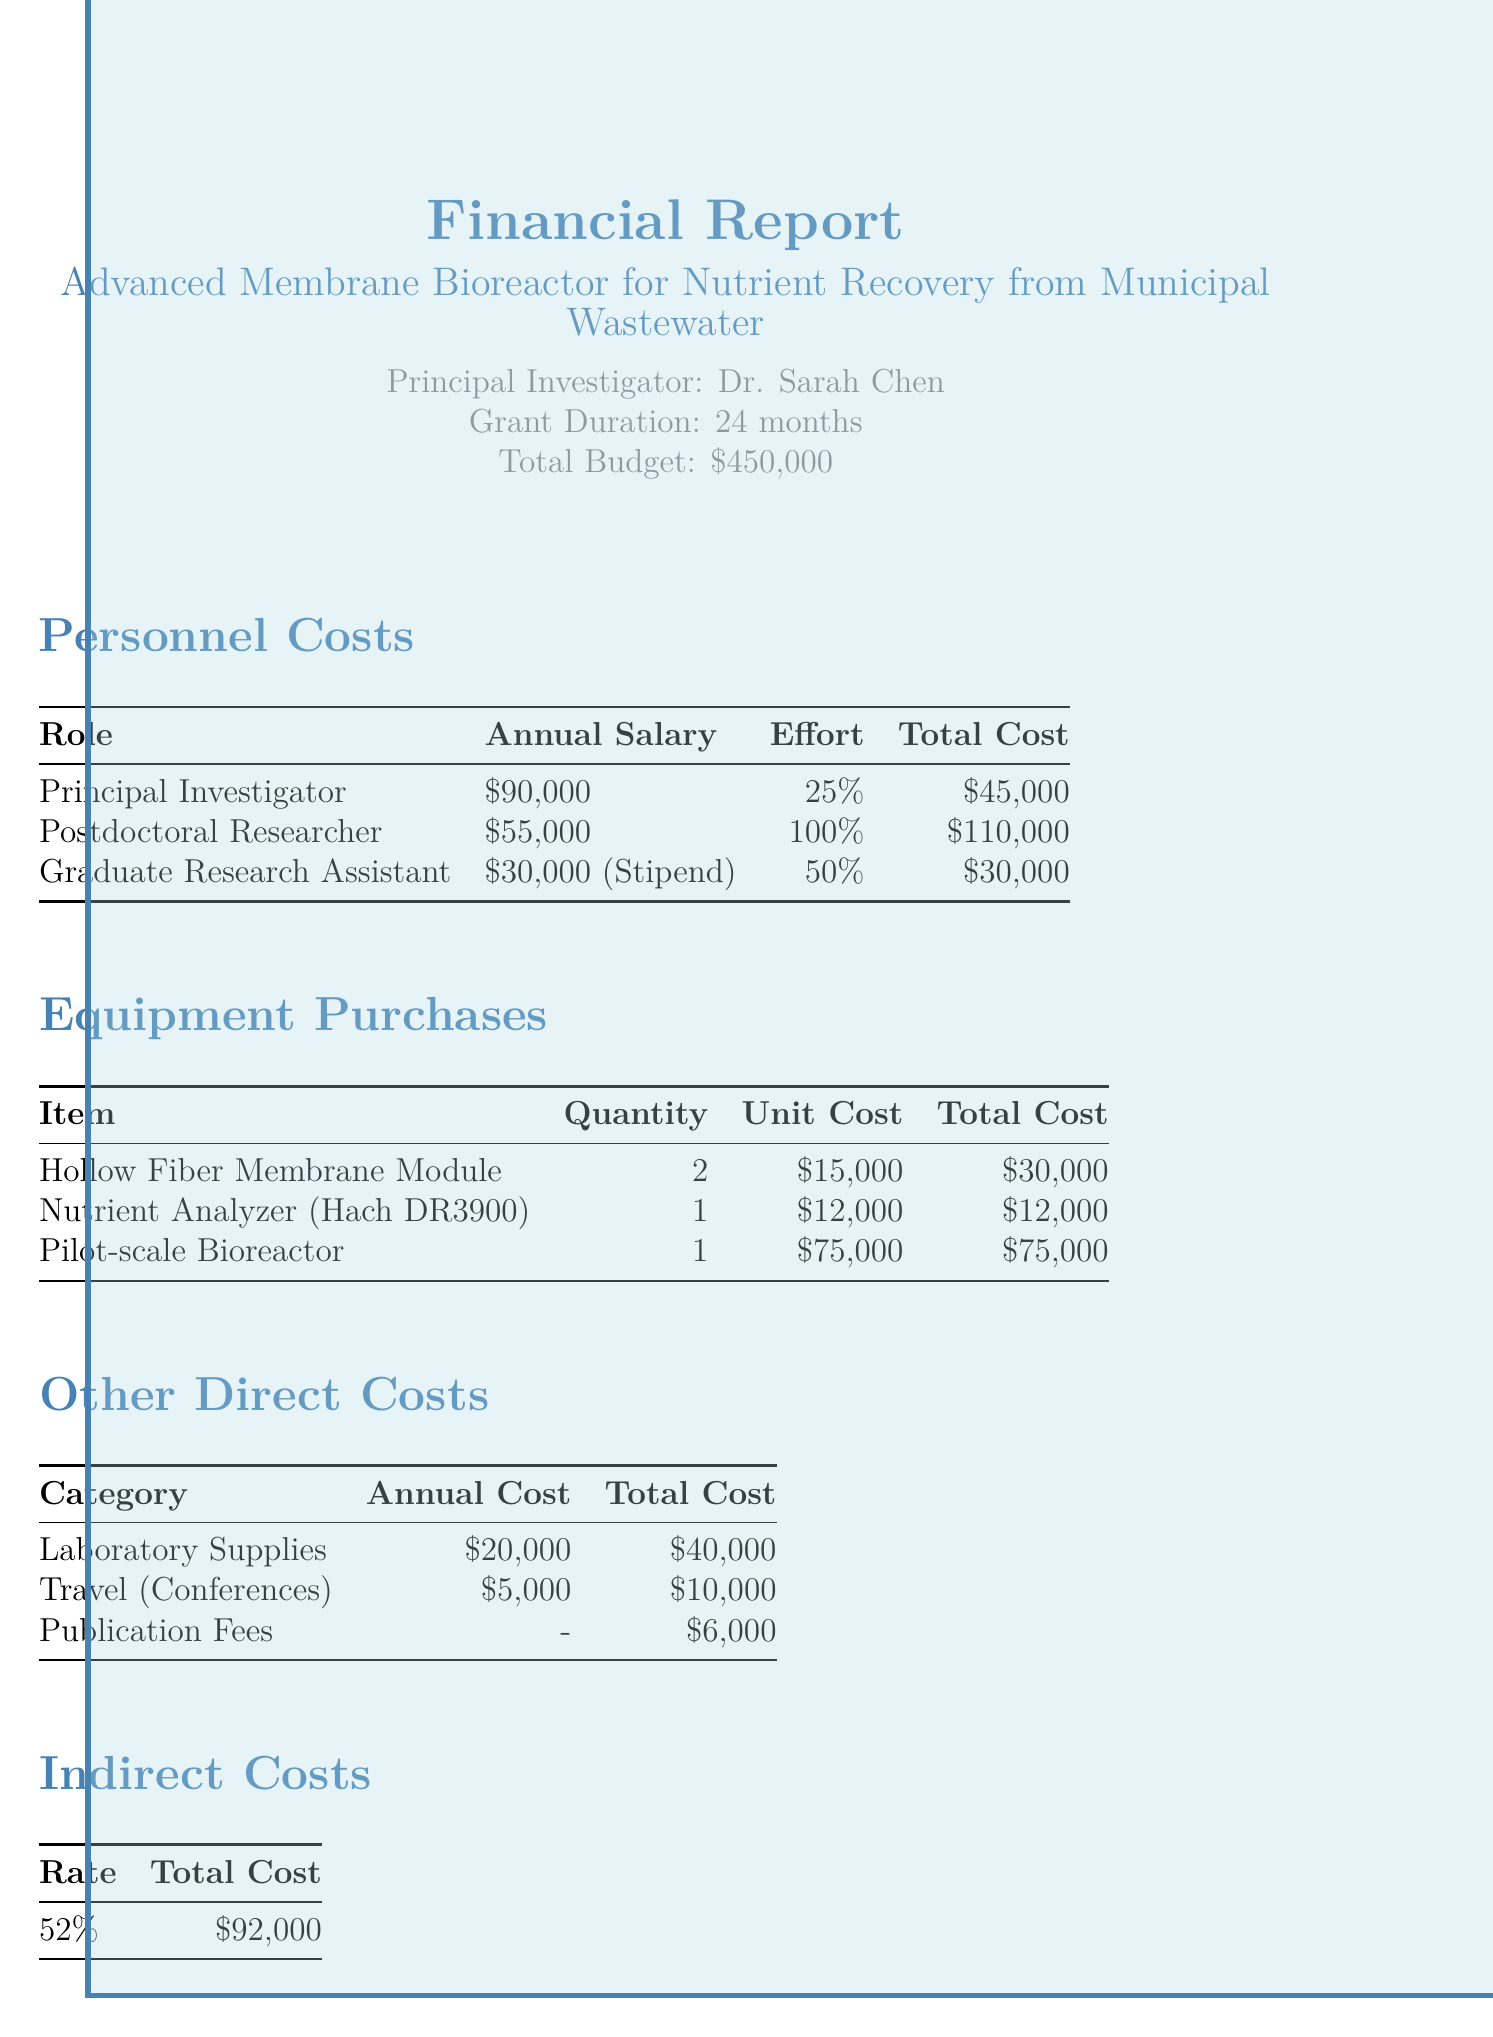what is the project title? The project title is provided at the beginning of the document.
Answer: Advanced Membrane Bioreactor for Nutrient Recovery from Municipal Wastewater who is the principal investigator? The principal investigator's name is listed under the project information section.
Answer: Dr. Sarah Chen what is the total budget for the project? The total budget amount is stated clearly in the financial report.
Answer: $450,000 how much is the total cost for personnel? The total cost for personnel can be found by summing individual personnel costs detailed in the document.
Answer: $185,000 what is the unit cost of the Pilot-scale Bioreactor? The unit cost of each equipment item is listed in the equipment purchases section.
Answer: $75,000 what percentage of effort does the Postdoctoral Researcher contribute? The effort percentage for each role is specified in the personnel costs table.
Answer: 100% how much is allocated for publication fees? The total cost for publication fees is stated in the other direct costs section.
Answer: $6,000 what is the indirect cost rate applied in this budget? The indirect cost rate is provided in the indirect costs section of the document.
Answer: 52% what category has an annual cost of $20,000? The annual costs for different categories are listed in the other direct costs section.
Answer: Laboratory Supplies 